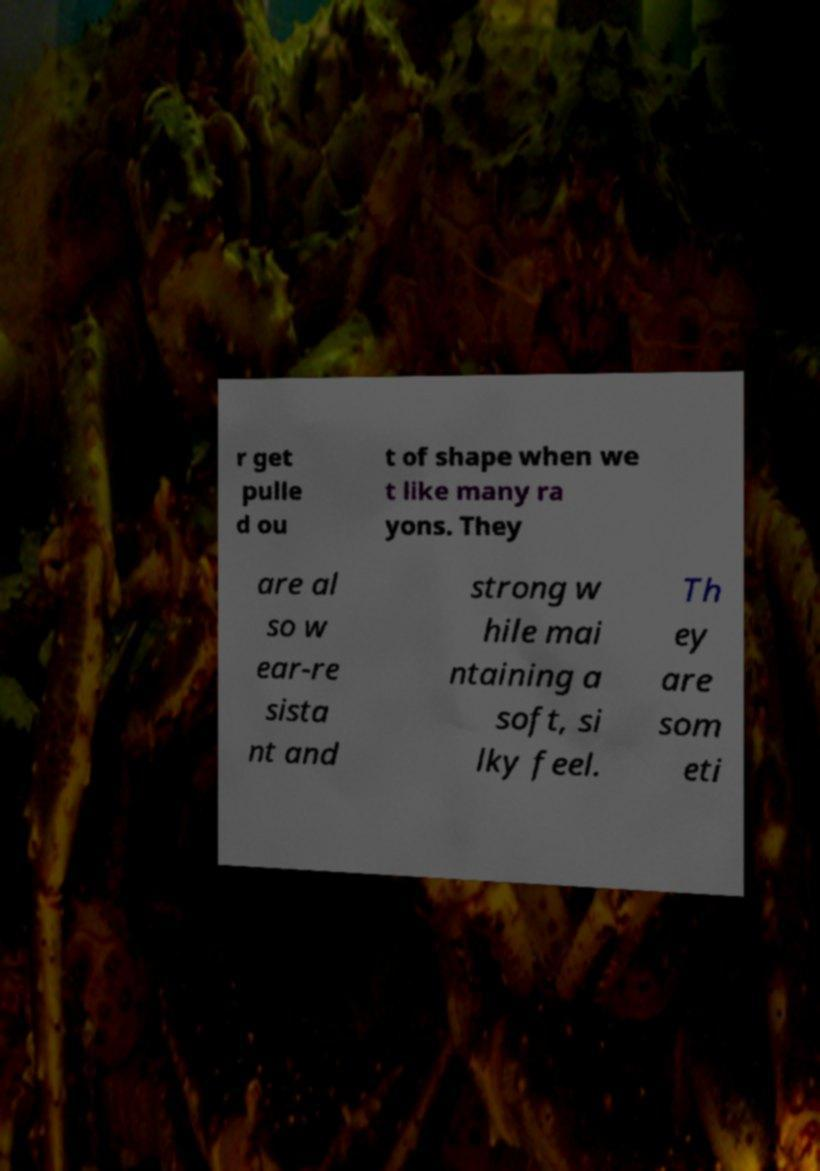Please read and relay the text visible in this image. What does it say? r get pulle d ou t of shape when we t like many ra yons. They are al so w ear-re sista nt and strong w hile mai ntaining a soft, si lky feel. Th ey are som eti 